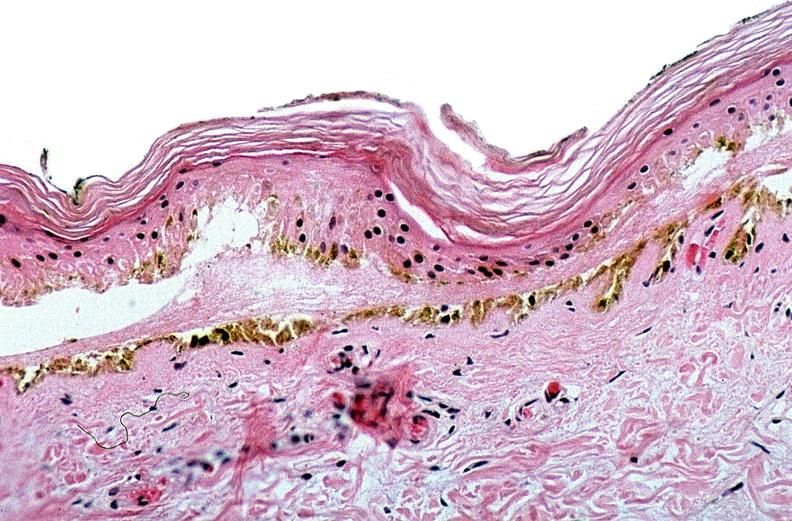where is this?
Answer the question using a single word or phrase. Skin 